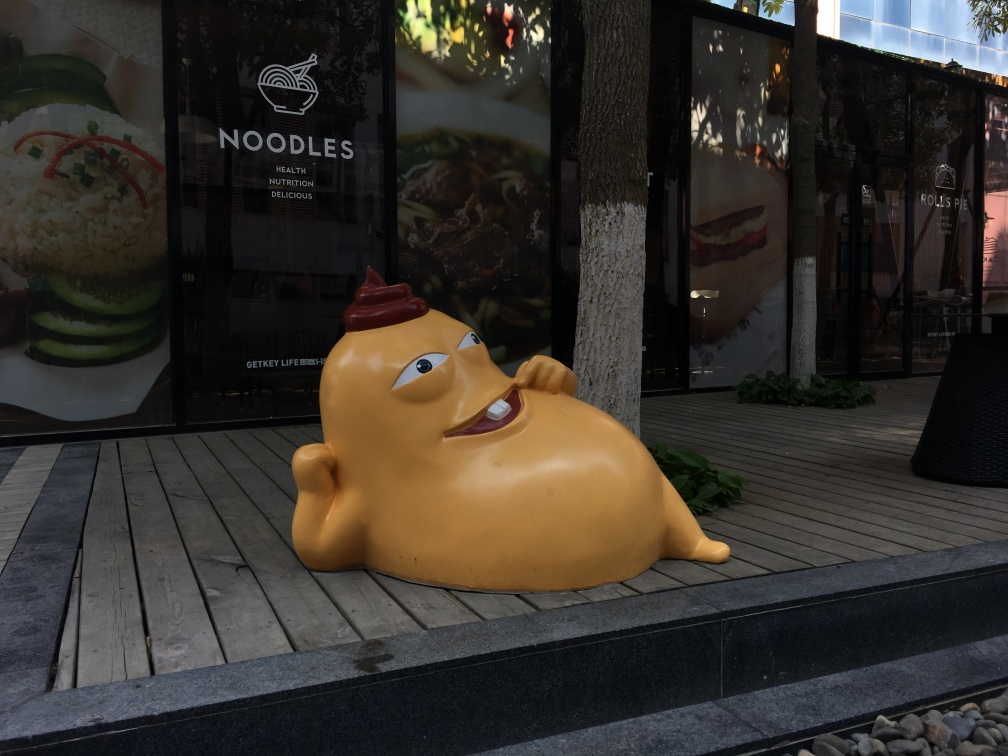What is the object in the foreground supposed to represent? The object in the foreground appears to be a whimsical sculpture of a potato with human-like features. It's lying down, and it even has a dollop of sauce on top, adding to the playful representation. Can you infer the purpose of this object being placed there? While I can't infer the creator's exact intentions, such sculptures are often used in commercial spaces to attract attention and create a memorable visual experience. It might be associated with a nearby food establishment, suggested by the background posters of food and the sign that reads 'NOODLES'. 